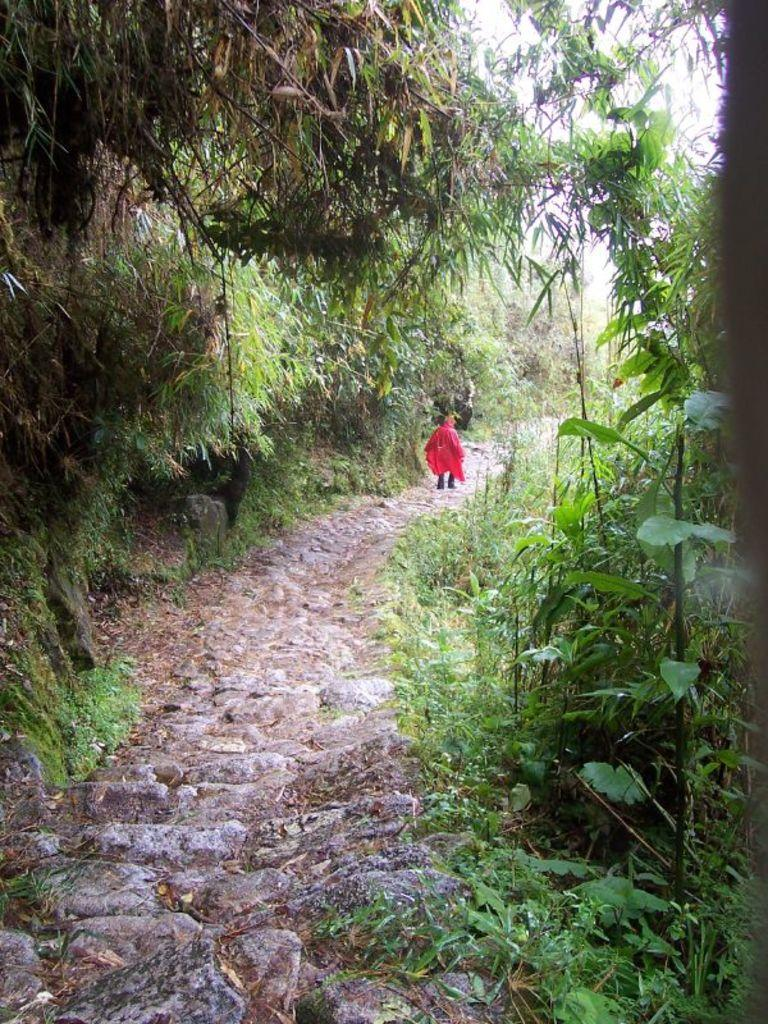What can be seen in the image that people walk on? There is a path in the image that people can walk on. Can you describe the person walking on the path? The person walking on the path is wearing a red dress. What type of vegetation is present on both sides of the path? There are green color plants on both the right and left sides of the path. What type of sheet is covering the dock in the image? There is no dock or sheet present in the image. 